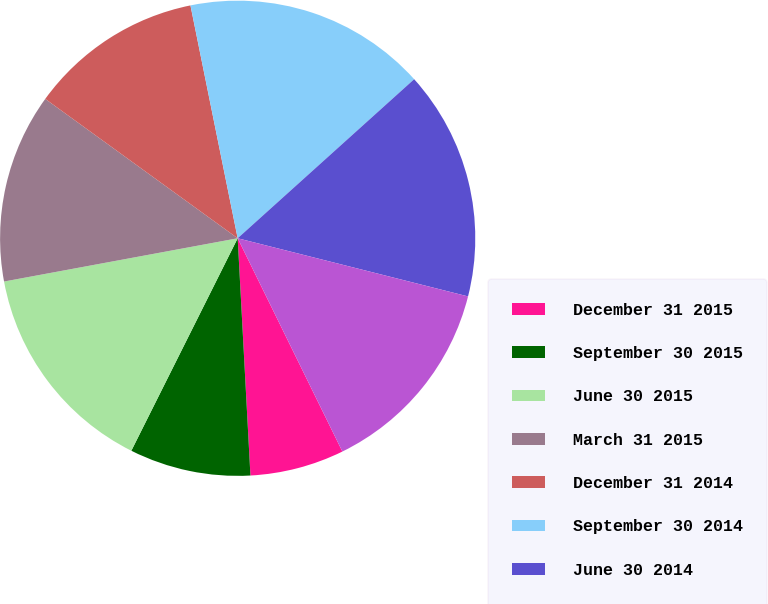Convert chart to OTSL. <chart><loc_0><loc_0><loc_500><loc_500><pie_chart><fcel>December 31 2015<fcel>September 30 2015<fcel>June 30 2015<fcel>March 31 2015<fcel>December 31 2014<fcel>September 30 2014<fcel>June 30 2014<fcel>March 31 2014<nl><fcel>6.41%<fcel>8.24%<fcel>14.7%<fcel>12.89%<fcel>11.84%<fcel>16.51%<fcel>15.61%<fcel>13.8%<nl></chart> 